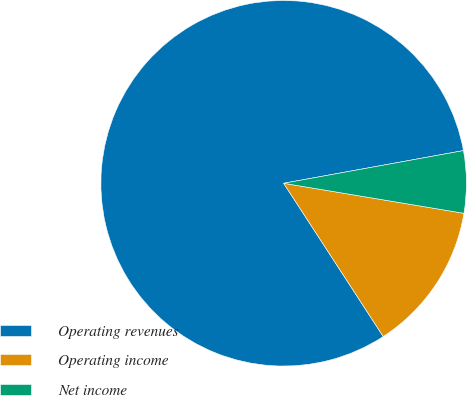Convert chart to OTSL. <chart><loc_0><loc_0><loc_500><loc_500><pie_chart><fcel>Operating revenues<fcel>Operating income<fcel>Net income<nl><fcel>81.31%<fcel>13.2%<fcel>5.49%<nl></chart> 